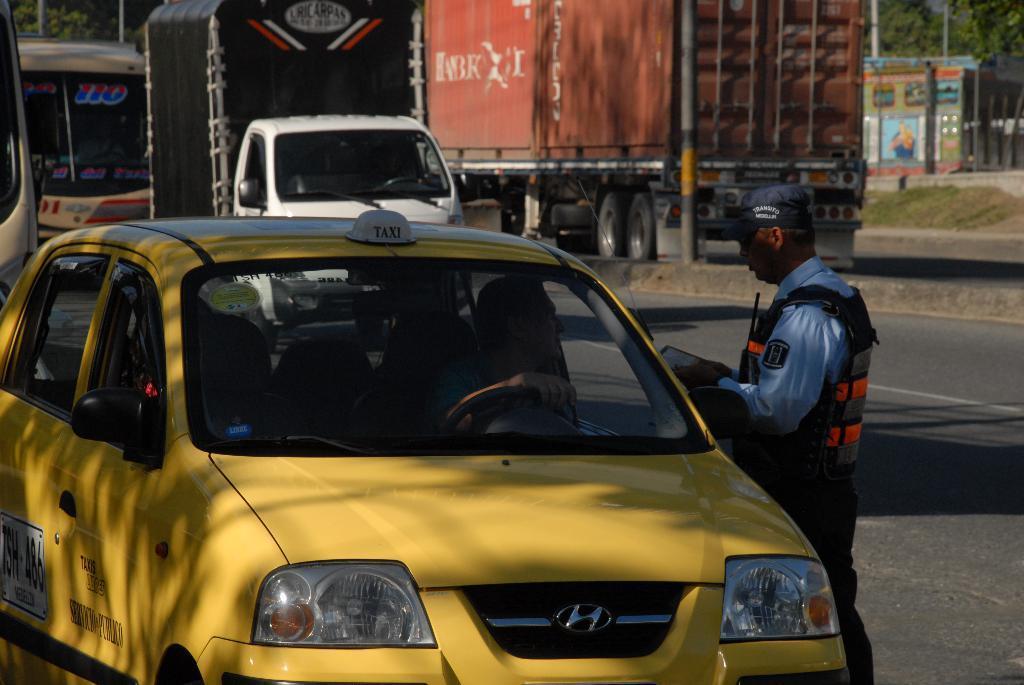In one or two sentences, can you explain what this image depicts? This picture is taken on the wide road and it is sunny. In this image, on the right side, we can see a man holding an object in his hand and standing in front of the car. In the middle of the image, we can see a car which is in yellow color. In the background, we can see few vehicles which are moving on the road, trees, pole. At the bottom, we can see a road. 